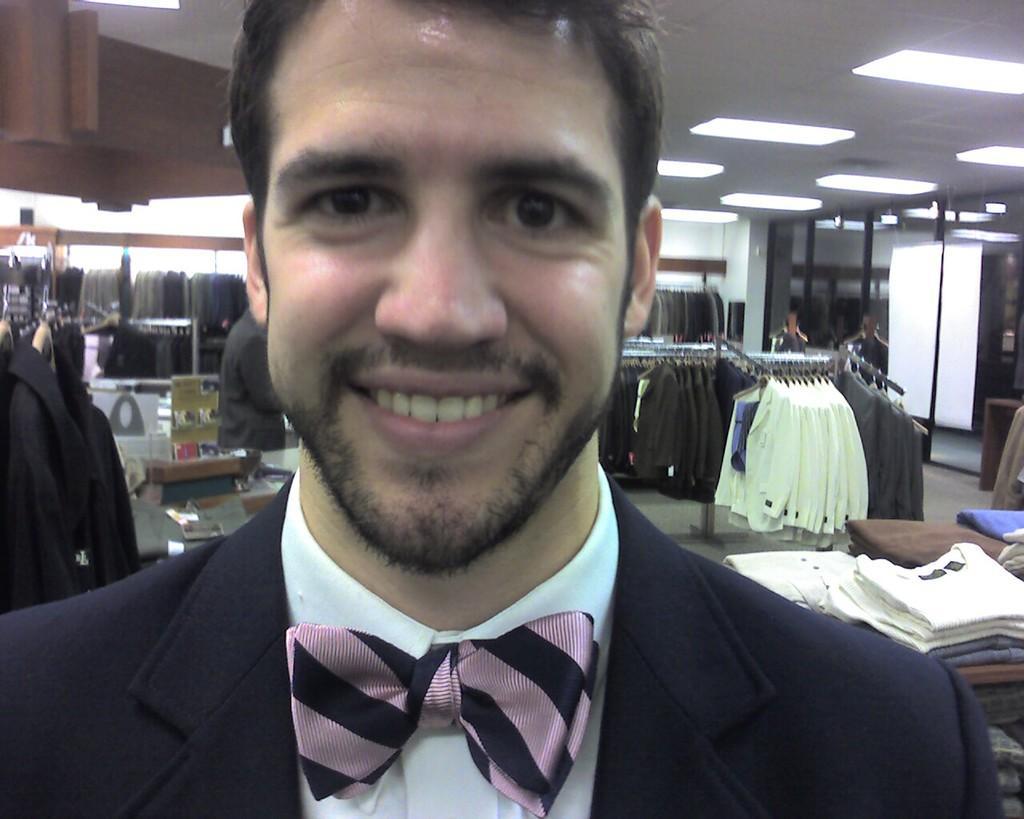Please provide a concise description of this image. In this image in the front there is a person smiling. In the background there are clothes, lights and there are persons and there is a wall. 